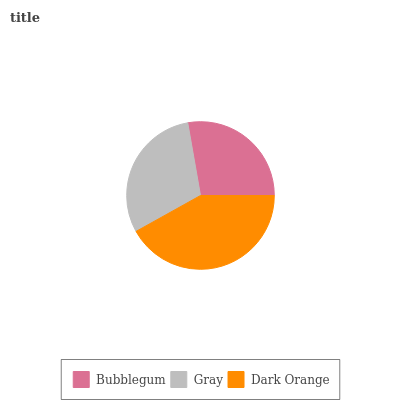Is Bubblegum the minimum?
Answer yes or no. Yes. Is Dark Orange the maximum?
Answer yes or no. Yes. Is Gray the minimum?
Answer yes or no. No. Is Gray the maximum?
Answer yes or no. No. Is Gray greater than Bubblegum?
Answer yes or no. Yes. Is Bubblegum less than Gray?
Answer yes or no. Yes. Is Bubblegum greater than Gray?
Answer yes or no. No. Is Gray less than Bubblegum?
Answer yes or no. No. Is Gray the high median?
Answer yes or no. Yes. Is Gray the low median?
Answer yes or no. Yes. Is Bubblegum the high median?
Answer yes or no. No. Is Bubblegum the low median?
Answer yes or no. No. 